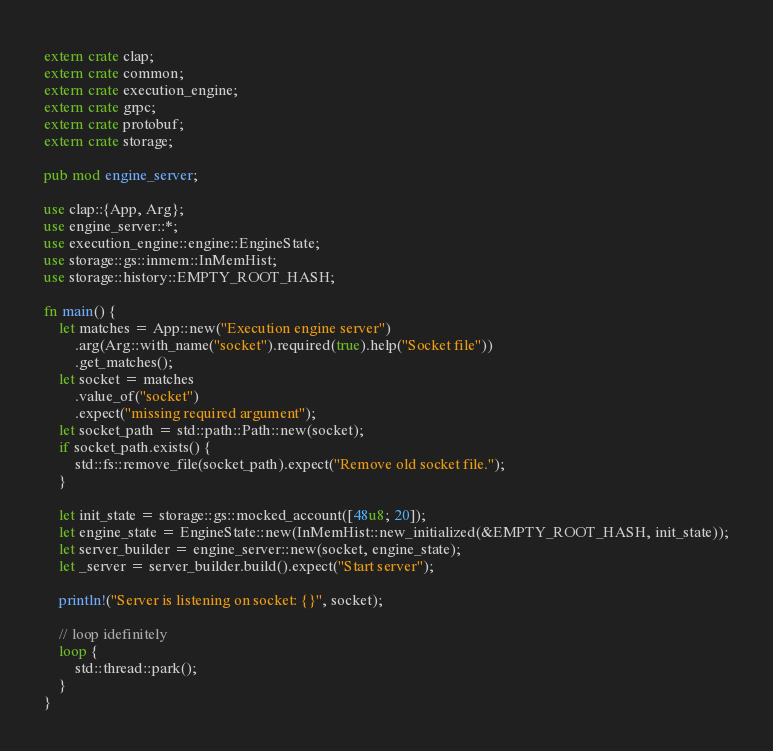Convert code to text. <code><loc_0><loc_0><loc_500><loc_500><_Rust_>extern crate clap;
extern crate common;
extern crate execution_engine;
extern crate grpc;
extern crate protobuf;
extern crate storage;

pub mod engine_server;

use clap::{App, Arg};
use engine_server::*;
use execution_engine::engine::EngineState;
use storage::gs::inmem::InMemHist;
use storage::history::EMPTY_ROOT_HASH;

fn main() {
    let matches = App::new("Execution engine server")
        .arg(Arg::with_name("socket").required(true).help("Socket file"))
        .get_matches();
    let socket = matches
        .value_of("socket")
        .expect("missing required argument");
    let socket_path = std::path::Path::new(socket);
    if socket_path.exists() {
        std::fs::remove_file(socket_path).expect("Remove old socket file.");
    }

    let init_state = storage::gs::mocked_account([48u8; 20]);
    let engine_state = EngineState::new(InMemHist::new_initialized(&EMPTY_ROOT_HASH, init_state));
    let server_builder = engine_server::new(socket, engine_state);
    let _server = server_builder.build().expect("Start server");

    println!("Server is listening on socket: {}", socket);

    // loop idefinitely
    loop {
        std::thread::park();
    }
}
</code> 